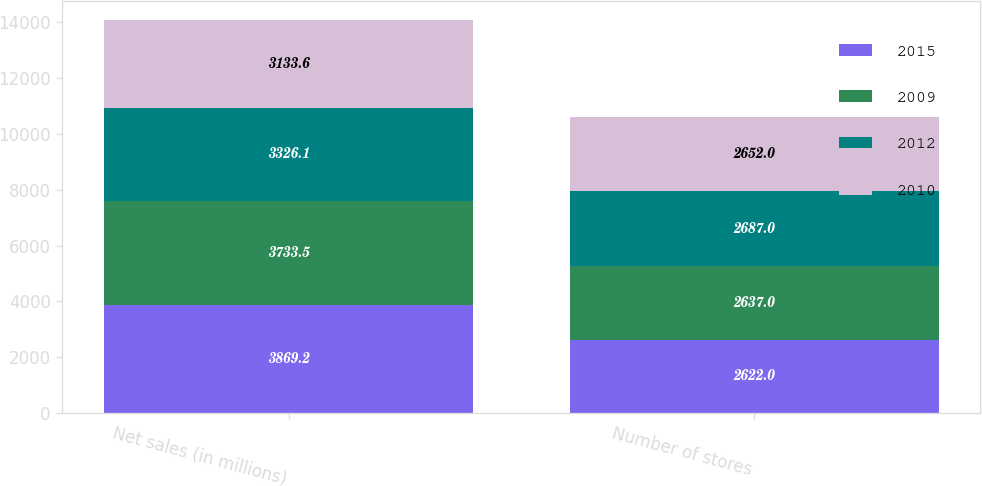<chart> <loc_0><loc_0><loc_500><loc_500><stacked_bar_chart><ecel><fcel>Net sales (in millions)<fcel>Number of stores<nl><fcel>2015<fcel>3869.2<fcel>2622<nl><fcel>2009<fcel>3733.5<fcel>2637<nl><fcel>2012<fcel>3326.1<fcel>2687<nl><fcel>2010<fcel>3133.6<fcel>2652<nl></chart> 